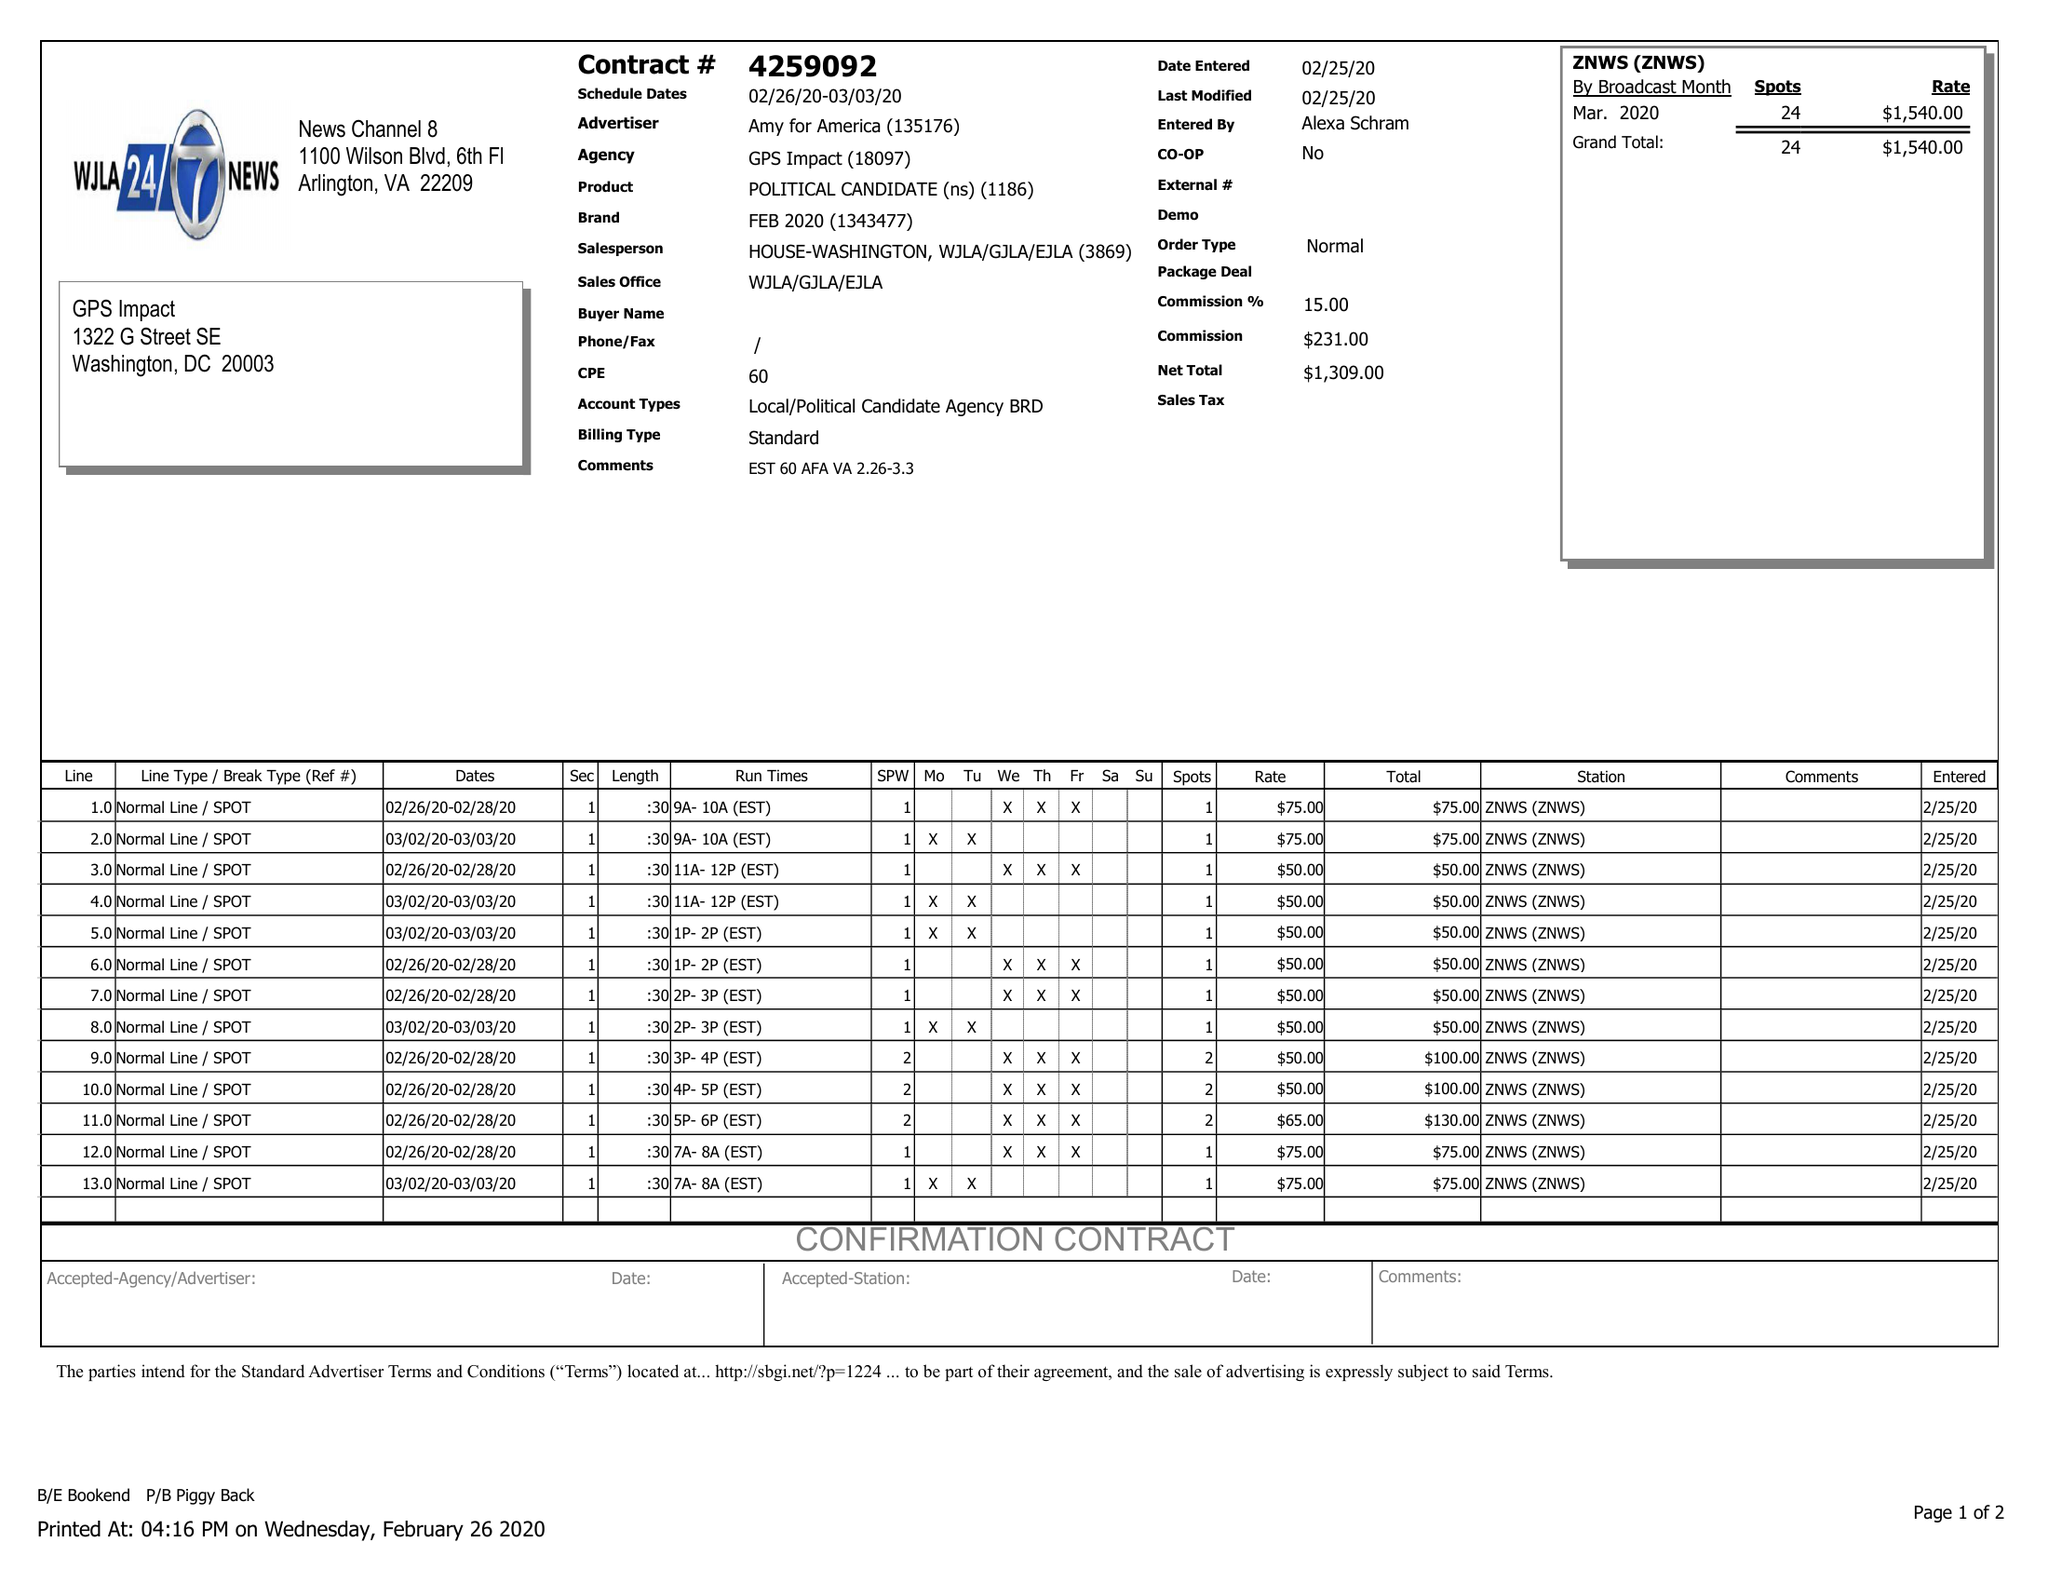What is the value for the advertiser?
Answer the question using a single word or phrase. AMY FOR AMERICA 